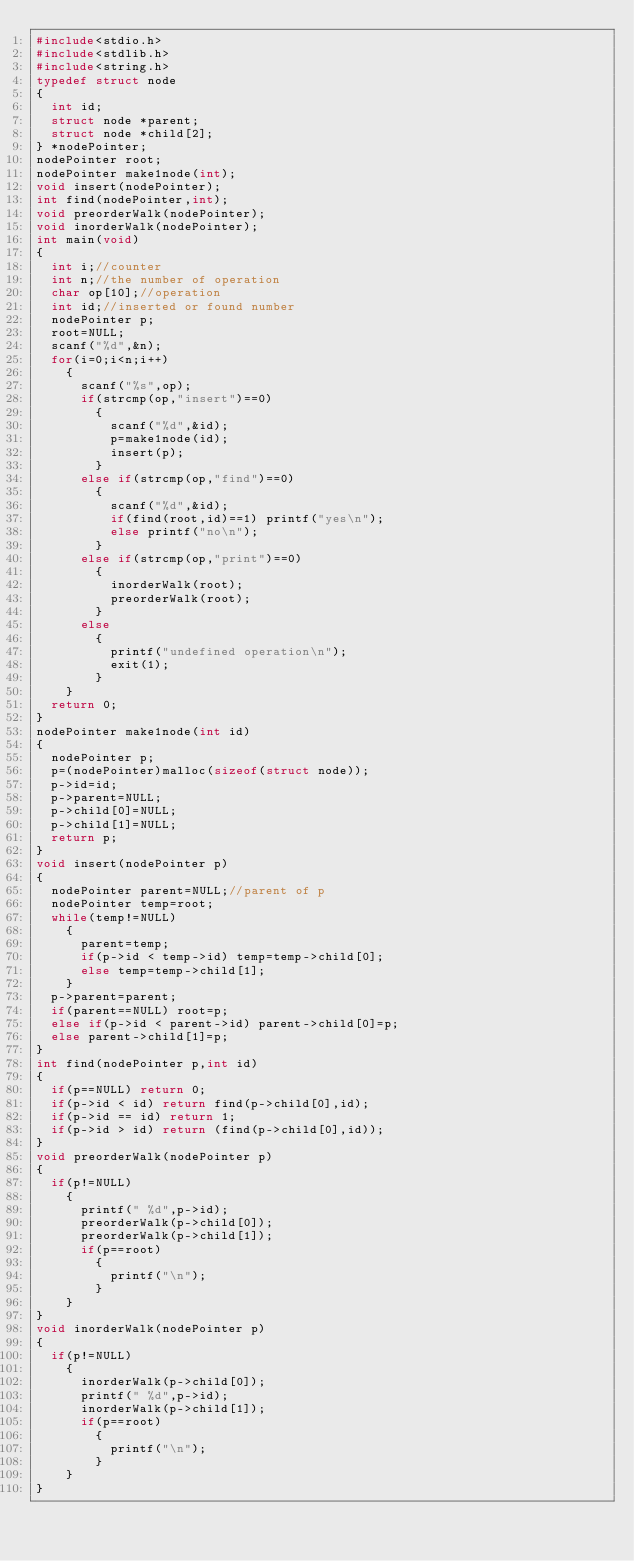Convert code to text. <code><loc_0><loc_0><loc_500><loc_500><_C_>#include<stdio.h>
#include<stdlib.h>
#include<string.h>
typedef struct node
{
  int id;
  struct node *parent;
  struct node *child[2];
} *nodePointer;
nodePointer root;
nodePointer make1node(int);
void insert(nodePointer);
int find(nodePointer,int);
void preorderWalk(nodePointer);
void inorderWalk(nodePointer);
int main(void)
{
  int i;//counter
  int n;//the number of operation
  char op[10];//operation
  int id;//inserted or found number
  nodePointer p;
  root=NULL;
  scanf("%d",&n);
  for(i=0;i<n;i++)
    {
      scanf("%s",op);
      if(strcmp(op,"insert")==0)
        {
          scanf("%d",&id);
          p=make1node(id);
          insert(p);
        }
      else if(strcmp(op,"find")==0)
        {
          scanf("%d",&id);
          if(find(root,id)==1) printf("yes\n");
          else printf("no\n");
        }
      else if(strcmp(op,"print")==0)
        {
          inorderWalk(root);
          preorderWalk(root);
        }
      else
        {
          printf("undefined operation\n");
          exit(1);
        }
    }
  return 0;
}
nodePointer make1node(int id)
{
  nodePointer p;
  p=(nodePointer)malloc(sizeof(struct node));
  p->id=id;
  p->parent=NULL;
  p->child[0]=NULL;
  p->child[1]=NULL;
  return p;
}
void insert(nodePointer p)
{
  nodePointer parent=NULL;//parent of p
  nodePointer temp=root;
  while(temp!=NULL)
    {
      parent=temp;
      if(p->id < temp->id) temp=temp->child[0];
      else temp=temp->child[1];
    }
  p->parent=parent;
  if(parent==NULL) root=p;
  else if(p->id < parent->id) parent->child[0]=p;
  else parent->child[1]=p;
}
int find(nodePointer p,int id)
{
  if(p==NULL) return 0;
  if(p->id < id) return find(p->child[0],id);
  if(p->id == id) return 1;
  if(p->id > id) return (find(p->child[0],id));
}
void preorderWalk(nodePointer p)
{
  if(p!=NULL)
    {
      printf(" %d",p->id);
      preorderWalk(p->child[0]);
      preorderWalk(p->child[1]);
      if(p==root)
        {
          printf("\n");
        }
    }
}
void inorderWalk(nodePointer p)
{
  if(p!=NULL)
    {
      inorderWalk(p->child[0]);
      printf(" %d",p->id);
      inorderWalk(p->child[1]);
      if(p==root)
        {
          printf("\n");
        }
    }
}

</code> 